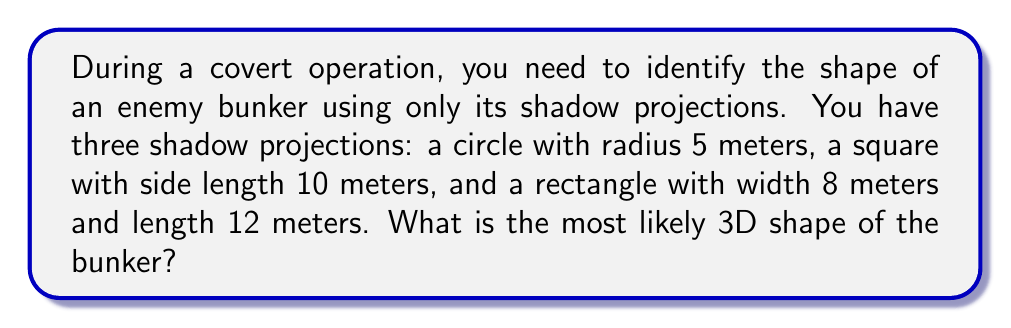Can you answer this question? To solve this inverse problem, we need to analyze the given shadow projections and determine the 3D shape that could produce all of them:

1. Circular projection (radius 5 meters):
   This suggests the object has a circular cross-section in one direction.

2. Square projection (side length 10 meters):
   This indicates the object has a square cross-section in another direction.

3. Rectangular projection (8m x 12m):
   This shows the object has a rectangular cross-section in a third direction.

The 3D shape that satisfies all these projections is a cylinder with a rectangular base:

- The circular projection is the view from the top or bottom of the cylinder.
- The square projection is the view from one side, where the height and width are equal.
- The rectangular projection is the view from another side, showing the full length and height.

Let's determine the dimensions:

- Cylinder radius: $r = 5$ meters (from the circular projection)
- Cylinder height: $h = 10$ meters (from the square projection)
- Cylinder length: $l = 12$ meters (from the rectangular projection)

The resulting shape is a rectangular cylinder with dimensions:

$$\text{radius} = 5\text{m}, \text{height} = 10\text{m}, \text{length} = 12\text{m}$$

This shape is consistent with typical bunker designs, combining the strength of a cylindrical structure with the practicality of a rectangular layout.
Answer: Rectangular cylinder (5m radius, 10m height, 12m length) 